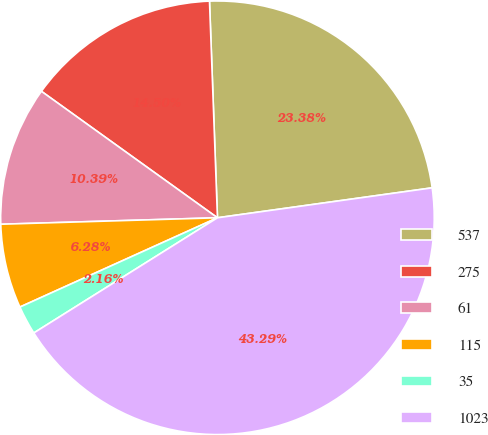Convert chart. <chart><loc_0><loc_0><loc_500><loc_500><pie_chart><fcel>537<fcel>275<fcel>61<fcel>115<fcel>35<fcel>1023<nl><fcel>23.38%<fcel>14.5%<fcel>10.39%<fcel>6.28%<fcel>2.16%<fcel>43.29%<nl></chart> 